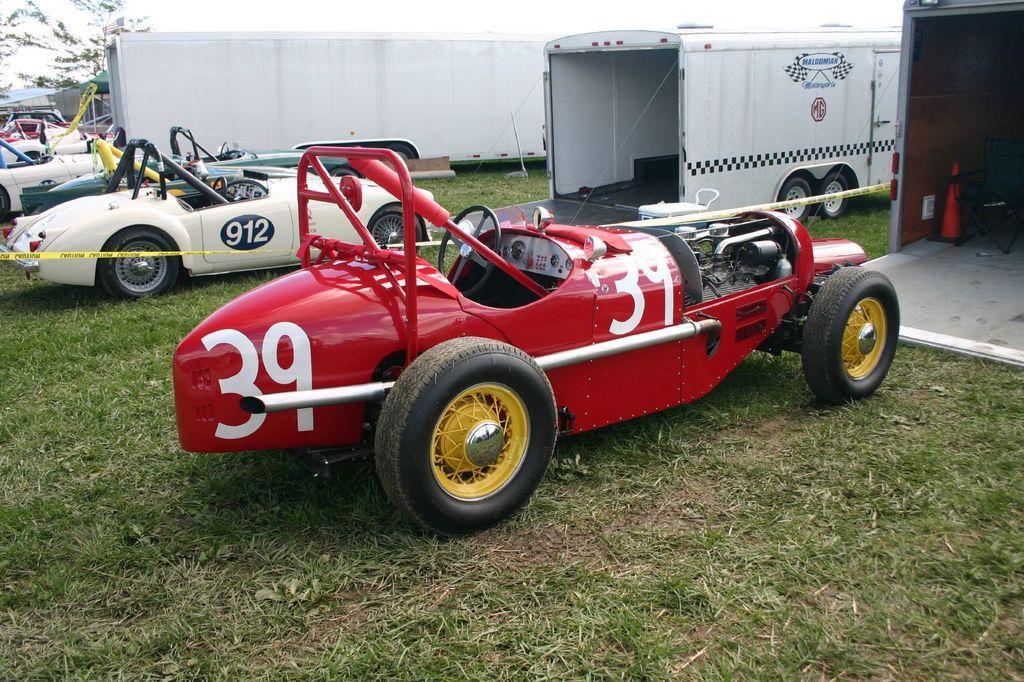Describe this image in one or two sentences. In this picture I can see vehicles on the grass. There is a chair, cone bar barricade, canopy tent, and in the background there are trees and the sky. 